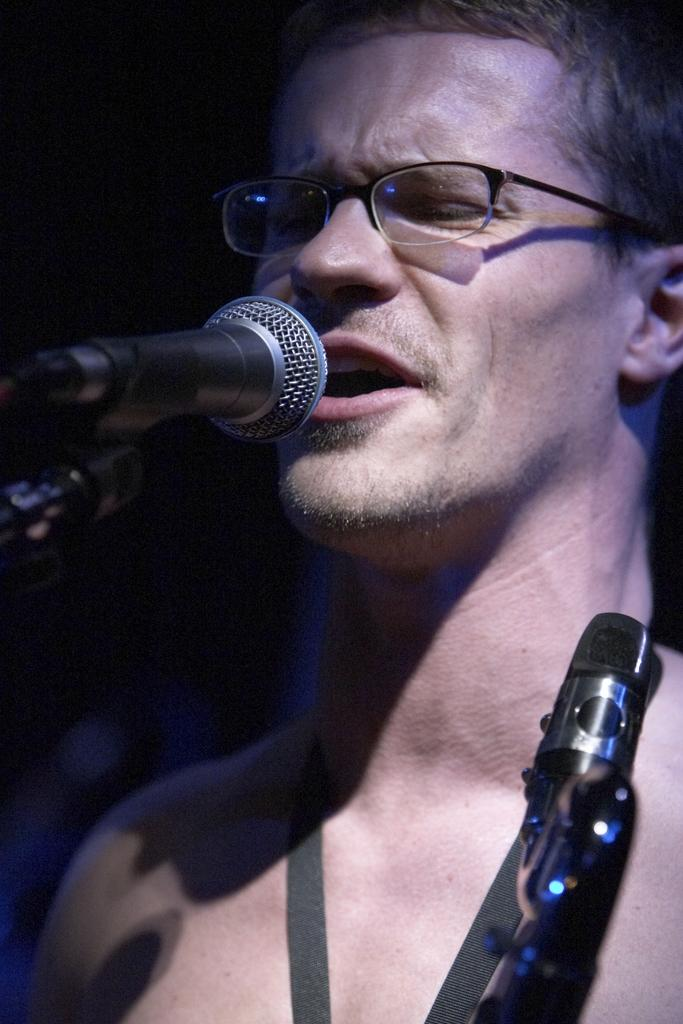What can be seen on the right side of the image? There is there a person on the right side of the image? What is the person wearing in the image? The person is wearing spectacles in the image. What is the person doing in the image? The person is singing in front of a microphone in the image. How is the microphone positioned in the image? The microphone is attached to a stand in the image. What is the color of the background in the image? The background of the image is dark in color. What type of harmony can be heard between the person and the cannon in the image? There is no cannon present in the image, and therefore no such harmony can be heard. 